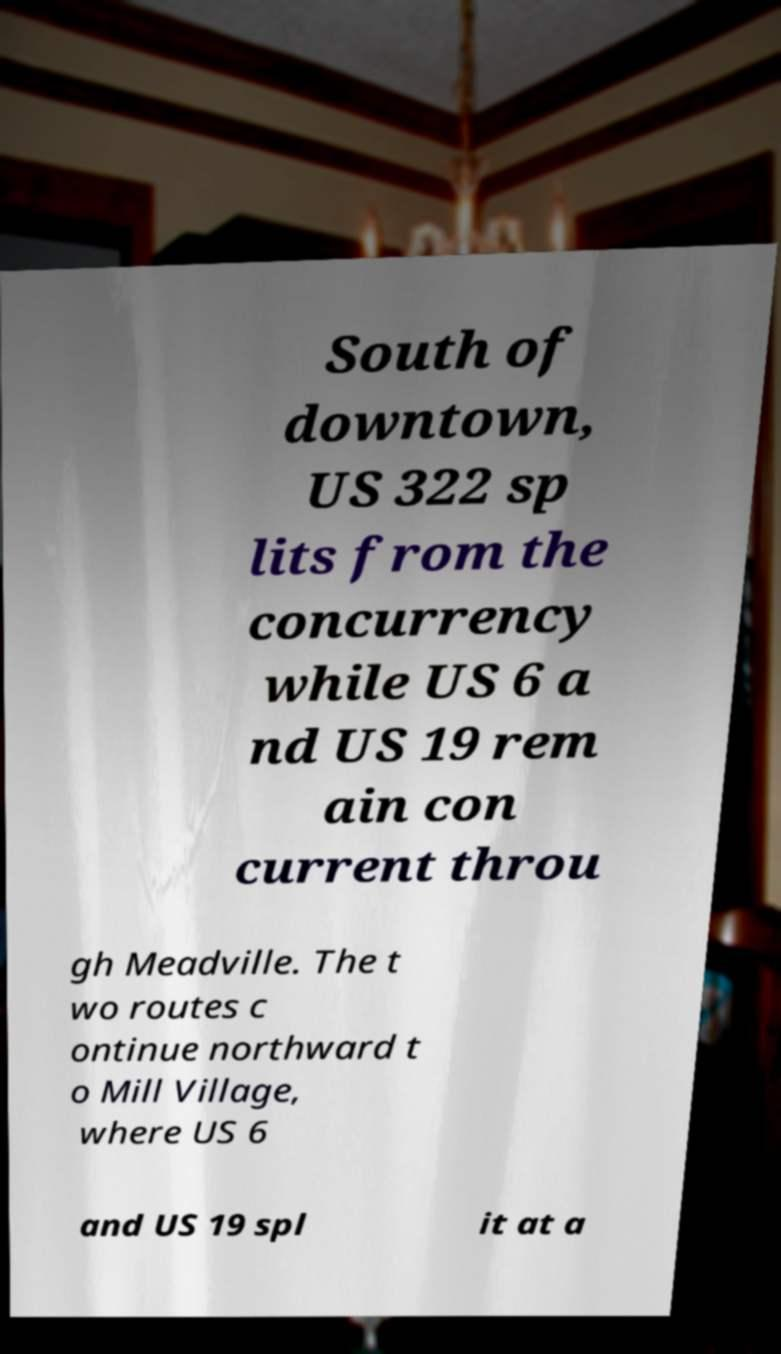Could you extract and type out the text from this image? South of downtown, US 322 sp lits from the concurrency while US 6 a nd US 19 rem ain con current throu gh Meadville. The t wo routes c ontinue northward t o Mill Village, where US 6 and US 19 spl it at a 